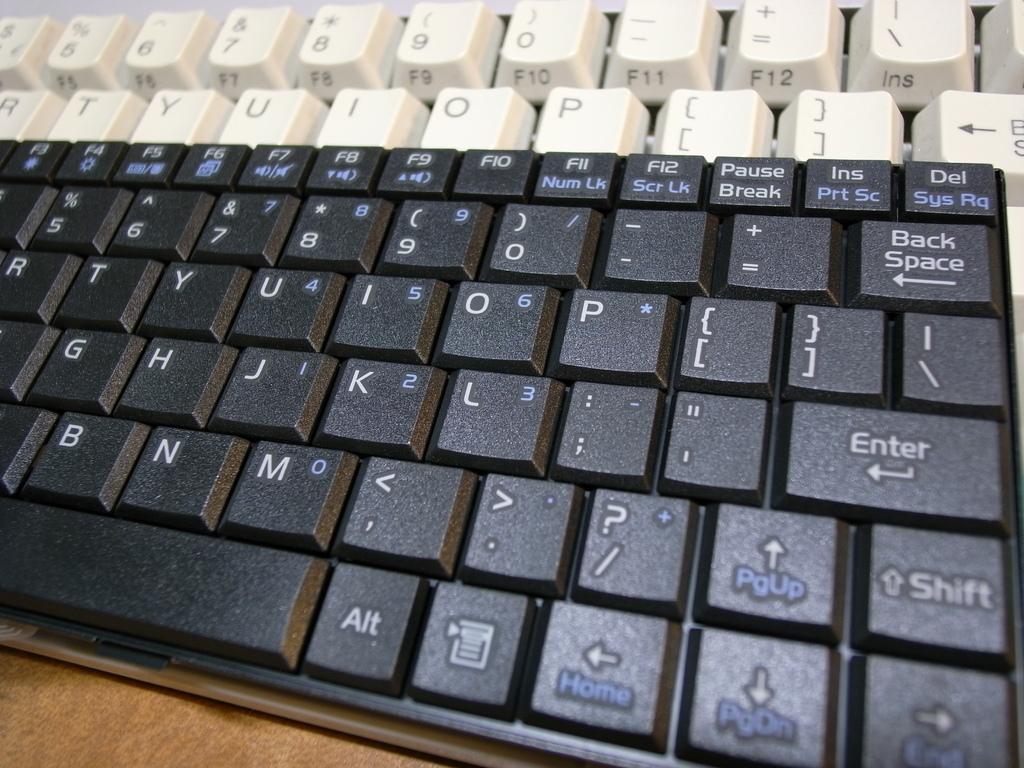Is there an enter key on this keyboard?
Provide a succinct answer. Yes. 